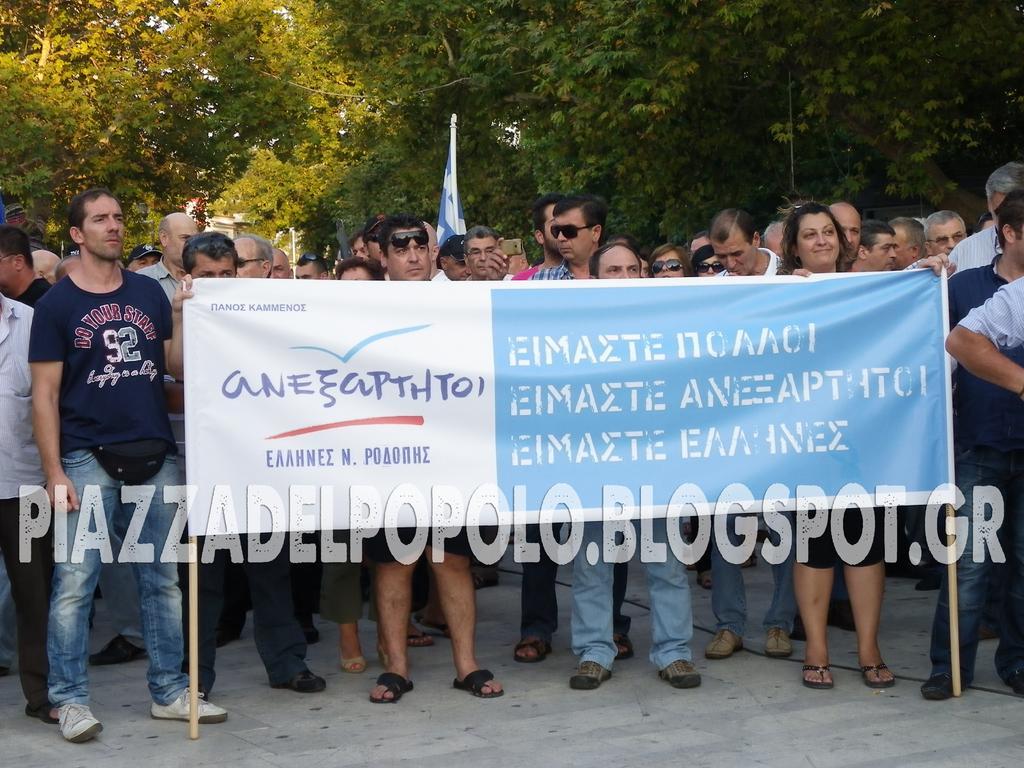Can you describe this image briefly? In the background we can see the trees. In this picture we can see a flag. We can see the people. Among them few wore goggles and few are holding a banner. It seems like they are protesting. We can see watermark and the road. 